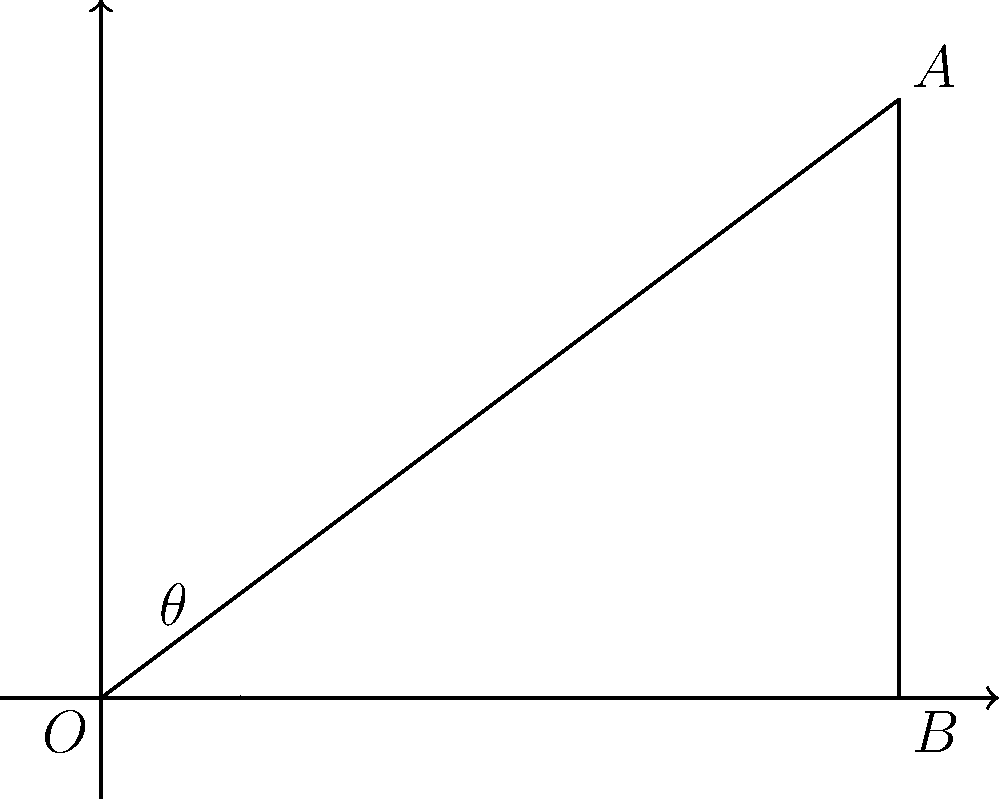As a naval officer, you're tasked with determining the optimal angle for a ship's anchor chain. Given that the anchor point A is 4 units horizontally and 3 units vertically from the ship's position O, what is the angle $\theta$ (in degrees) between the anchor chain OA and the horizontal plane OB? To solve this problem, we'll use vector analysis and trigonometry:

1. Identify the components of the vector OA:
   Horizontal component (x) = 4 units
   Vertical component (y) = 3 units

2. The angle $\theta$ can be calculated using the arctangent function:
   $\theta = \arctan(\frac{y}{x})$

3. Substitute the values:
   $\theta = \arctan(\frac{3}{4})$

4. Calculate the result:
   $\theta \approx 36.87°$

5. Round to the nearest degree:
   $\theta \approx 37°$

This angle represents the optimal inclination for the anchor chain, balancing the horizontal and vertical forces acting on the ship and anchor system.
Answer: 37° 